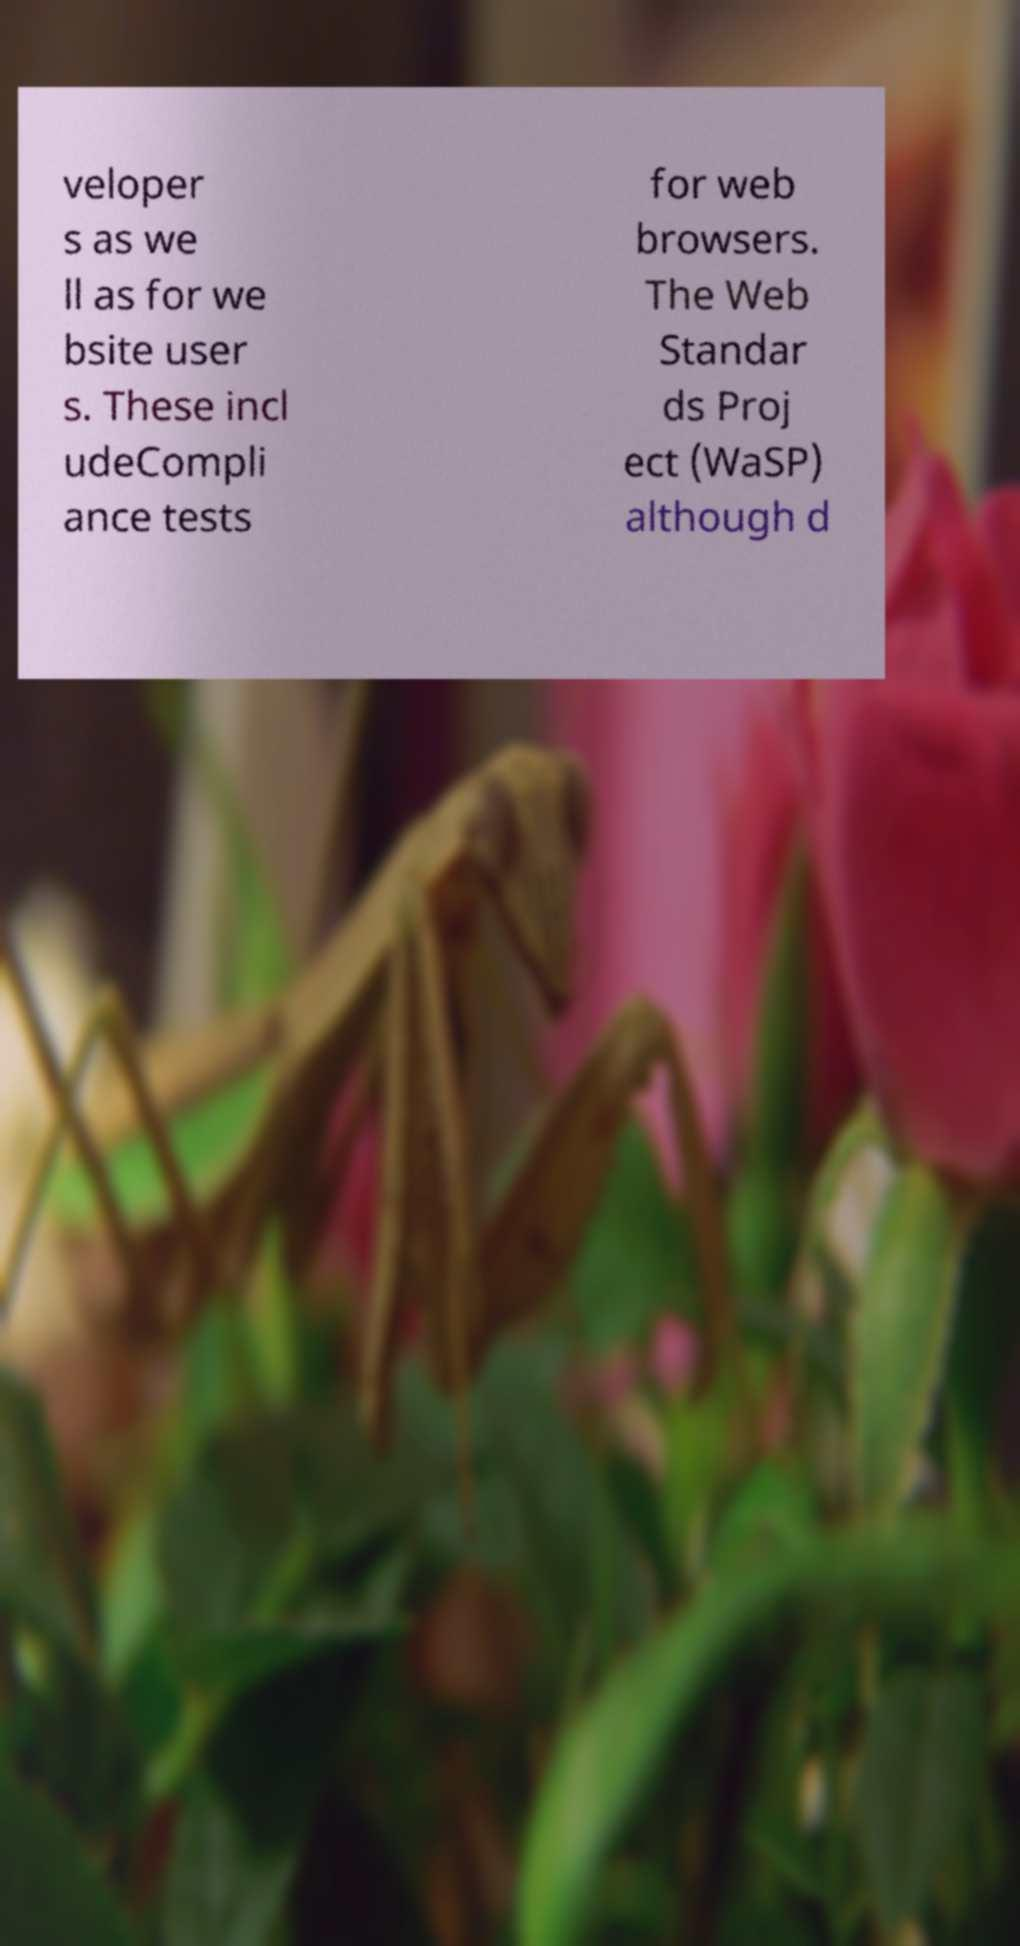There's text embedded in this image that I need extracted. Can you transcribe it verbatim? veloper s as we ll as for we bsite user s. These incl udeCompli ance tests for web browsers. The Web Standar ds Proj ect (WaSP) although d 